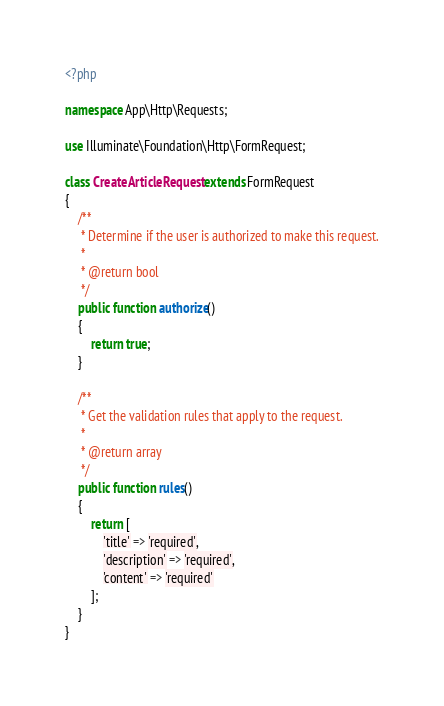Convert code to text. <code><loc_0><loc_0><loc_500><loc_500><_PHP_><?php

namespace App\Http\Requests;

use Illuminate\Foundation\Http\FormRequest;

class CreateArticleRequest extends FormRequest
{
    /**
     * Determine if the user is authorized to make this request.
     *
     * @return bool
     */
    public function authorize()
    {
        return true;
    }

    /**
     * Get the validation rules that apply to the request.
     *
     * @return array
     */
    public function rules()
    {
        return [
            'title' => 'required',
            'description' => 'required',
            'content' => 'required'
        ];
    }
}
</code> 